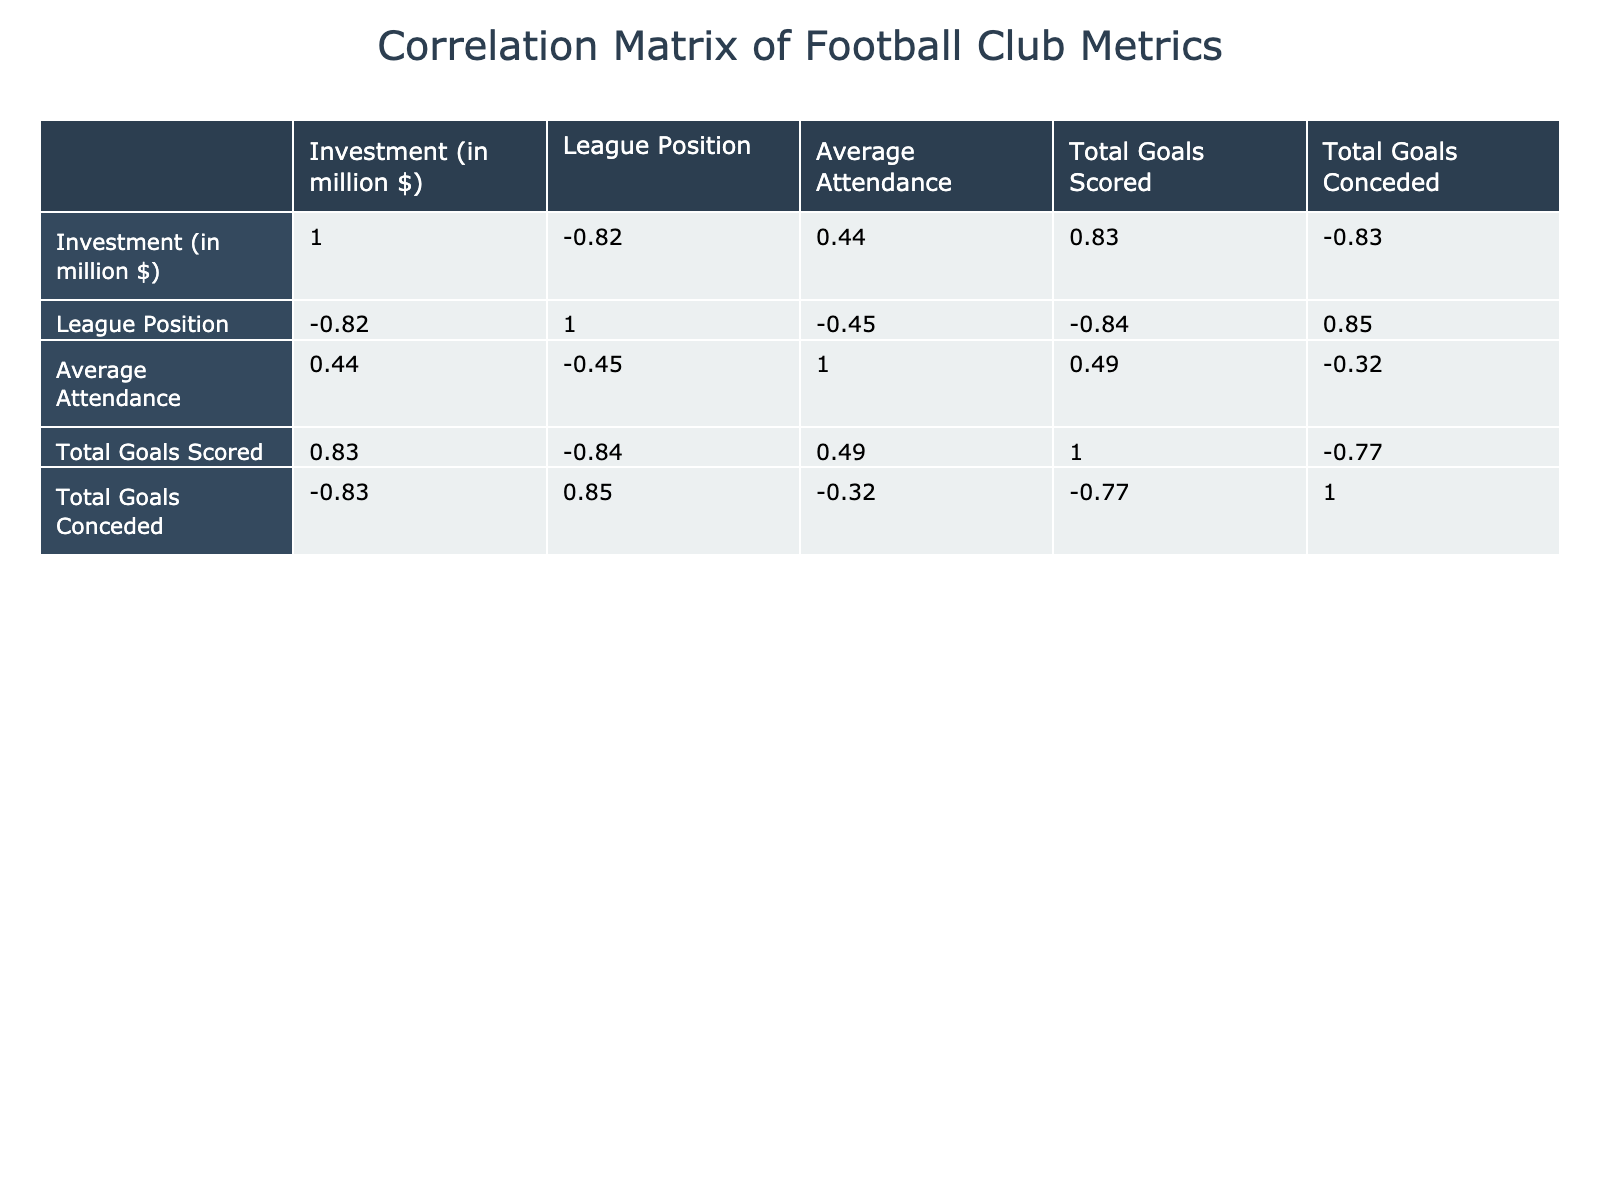What is the highest investment among the football clubs? The table shows that Bayern Munich and Paris Saint-Germain both have the highest investment amount at 500 million dollars. This can be verified by looking at the "Investment (in million $)" column to find the maximum value.
Answer: 500 million dollars Which club has the lowest league position? The table indicates that FC Barcelona and Manchester City have the lowest league position, ranked 1. We can find this by examining the "League Position" column for the lowest number.
Answer: FC Barcelona and Manchester City What is the average attendance for clubs that invested more than 300 million dollars? The clubs that invested more than 300 million dollars are FC Barcelona, Real Madrid, Manchester City, Chelsea, Bayern Munich, and Paris Saint-Germain. Their attendances are 70000, 80000, 55000, 40000, 75000, and 49000, respectively. Adding these together gives 314000, and dividing by 6 gives an average attendance of 52333.33.
Answer: 52333.33 Is there a club with more total goals scored than total goals conceded? Yes, Manchester City (100 scored, 35 conceded) and Bayern Munich (95 scored, 30 conceded) have scored more goals than they conceded, as can be seen by comparing the "Total Goals Scored" and "Total Goals Conceded" columns.
Answer: Yes What is the difference in investment between the club with the highest total goals scored and the club with the lowest? The club with the highest total goals scored is Manchester City (100 goals), while the club with the lowest is Lazio (60 goals). Their investments are 400 million and 100 million dollars, respectively. The difference is 400 - 100 = 300 million dollars.
Answer: 300 million dollars What percentage of the total goals scored by FC Barcelona does their total goals conceded represent? FC Barcelona scored 90 goals and conceded 38 goals. To find the percentage, we calculate (38 / 90) * 100, which gives approximately 42.22%.
Answer: 42.22% Which club has the best defensive record (lowest goals conceded)? Bayern Munich has the best defensive record, having conceded only 30 goals. This can be determined by looking for the minimum value in the "Total Goals Conceded" column.
Answer: Bayern Munich What is the total investment of clubs that ranked 5th or lower? The clubs ranked 5th or lower are Tottenham Hotspur, Arsenal, Chelsea, Juventus, Lazio, AC Milan, AS Roma, and Atletico Madrid. Their investments are 220, 250, 300, 300, 100, 200, 120, and 150 million dollars respectively. Summing these gives 1640 million dollars.
Answer: 1640 million dollars 